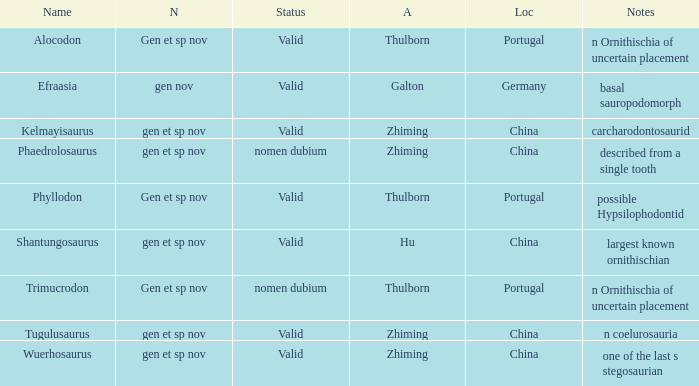What is the Novelty of the dinosaur that was named by the Author, Zhiming, and whose Notes are, "carcharodontosaurid"? Gen et sp nov. 